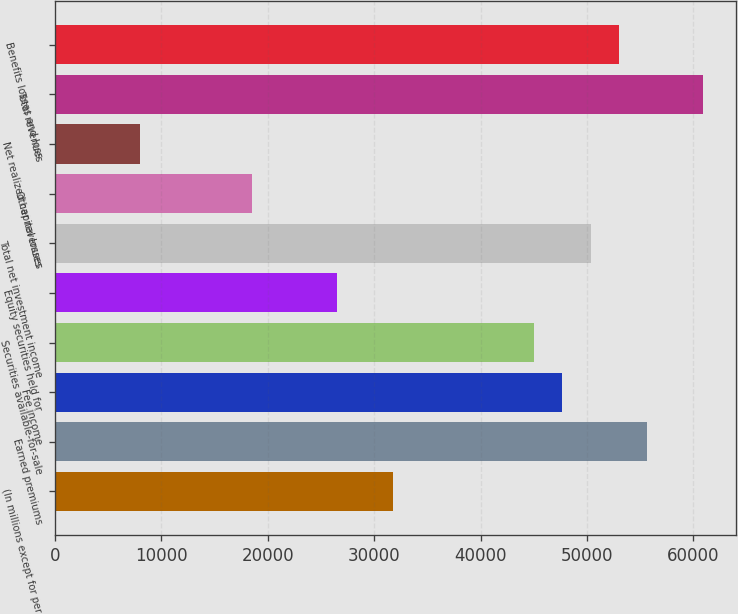Convert chart. <chart><loc_0><loc_0><loc_500><loc_500><bar_chart><fcel>(In millions except for per<fcel>Earned premiums<fcel>Fee income<fcel>Securities available-for-sale<fcel>Equity securities held for<fcel>Total net investment income<fcel>Other revenues<fcel>Net realized capital losses<fcel>Total revenues<fcel>Benefits losses and loss<nl><fcel>31799.7<fcel>55648.1<fcel>47698.6<fcel>45048.8<fcel>26500<fcel>50348.5<fcel>18550.5<fcel>7951.19<fcel>60947.8<fcel>52998.3<nl></chart> 